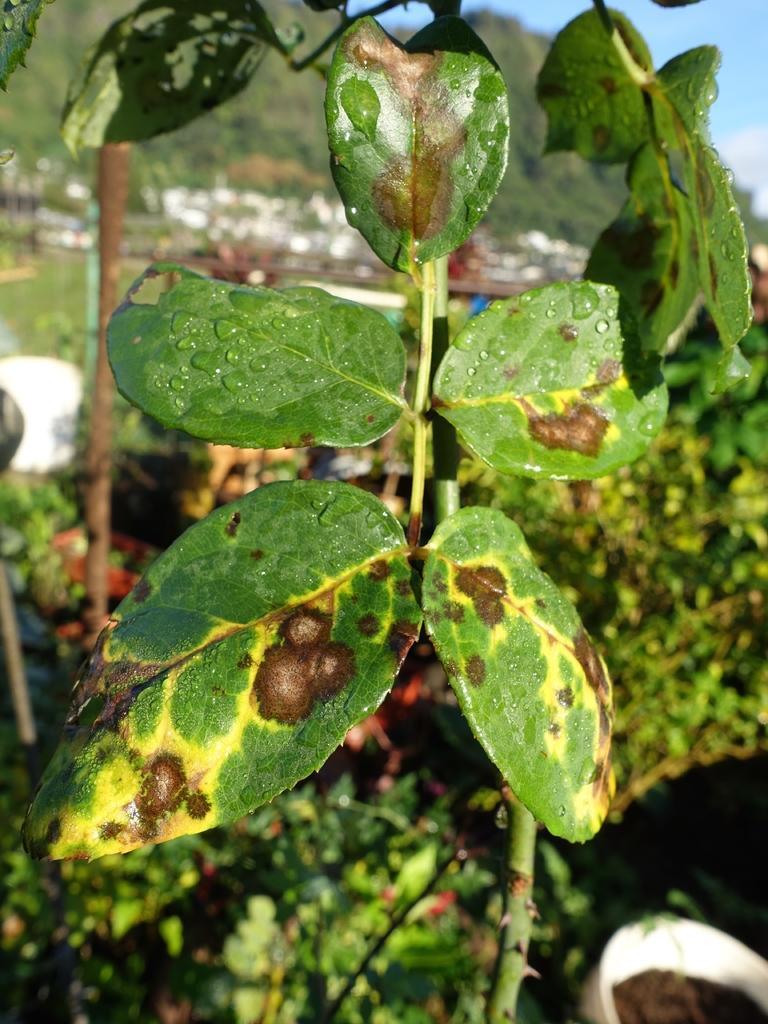How would you summarize this image in a sentence or two? In this image I can see there are leaves with yellow and brown color affected area, at the top it is the sky. 